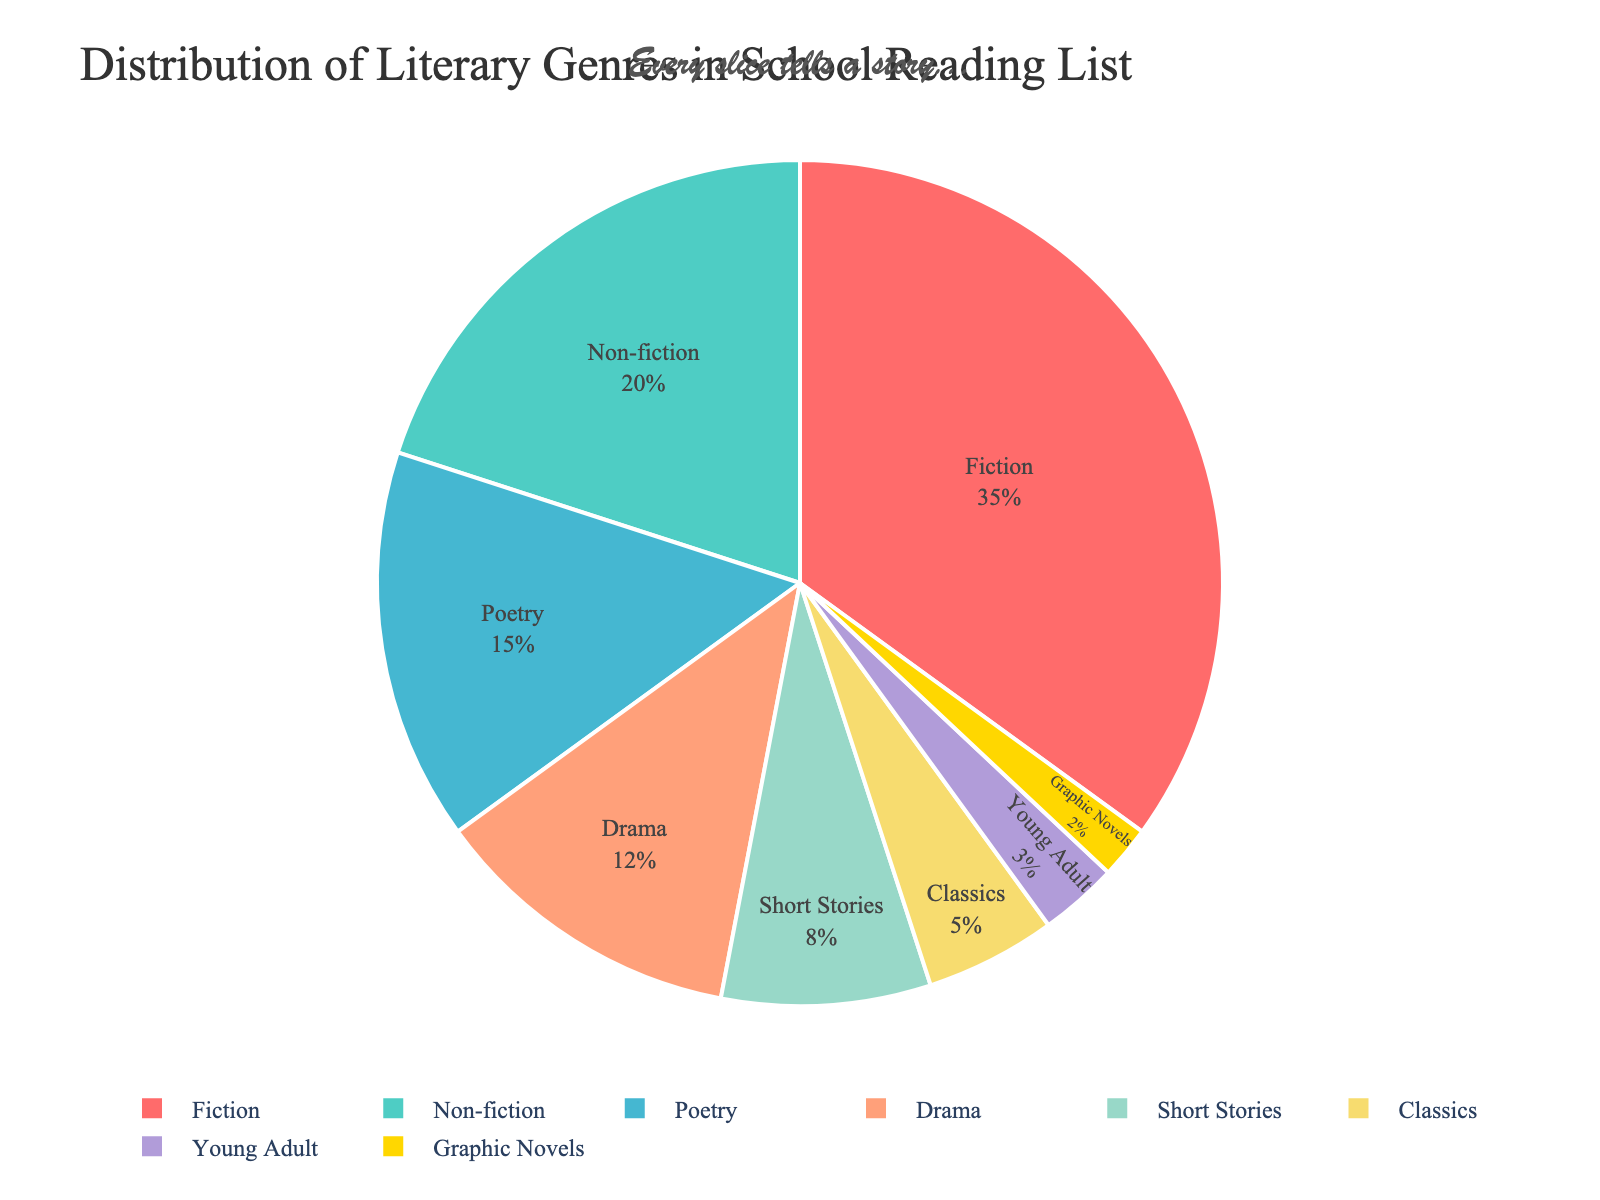What percentage of the reading list is composed of fiction and non-fiction genres combined? To determine this, look at the percentages of Fiction and Non-fiction: Fiction is 35% and Non-fiction is 20%. Adding these together, 35 + 20 = 55. Therefore, Fiction and Non-fiction combined make up 55% of the reading list.
Answer: 55% Which genre occupies the smallest portion of the pie chart? Observe the slice sizes and percentages labeled in the pie chart. Graphic Novels has the smallest slice, marked at 2%.
Answer: Graphic Novels Which is greater, the slice for Drama or the slice for Poetry? Compare the percentages directly from the chart: Poetry is 15% and Drama is 12%. Since 15% is greater than 12%, the Poetry slice is larger.
Answer: Poetry How does the percentage of Classics compare to the percentage of Young Adult genres? Look at the slices for Classics and Young Adult: Classics is 5% and Young Adult is 3%. Since 5% is greater than 3%, Classics has a larger portion.
Answer: Classics What is the difference in percentage between the largest and smallest genre slices? The largest slice is Fiction at 35%, and the smallest is Graphic Novels at 2%. Subtract the smallest from the largest: 35 - 2 = 33. Therefore, the difference is 33%.
Answer: 33% Which genre has a slice that is closest in size to that of Short Stories? Short Stories is 8%. Compare this with other slices: Classics (5%) and Young Adult (3%) are quite different. Drama is 12%. Poetry is 15%. Non-fiction is 20%. Fiction is 35%. Graphic Novels is 2%. The closest is Drama at 12%, as 8% and 12% are closer than other pairs.
Answer: Drama What is the sum of the percentages for Classics, Young Adult, and Graphic Novels? Sum up the percentages for Classics (5%), Young Adult (3%), and Graphic Novels (2%). 5 + 3 + 2 = 10. Therefore, these genres together sum to 10%.
Answer: 10% If Fiction and Non-fiction together make up more than half of the reading list, what is the combined percentage of all other genres? Fiction and Non-fiction are 55%. The entire pie chart sums to 100%. Subtract Fiction and Non-fiction: 100 - 55 = 45. Therefore, other genres combined make up 45%.
Answer: 45% How many genres have a percentage greater than 10%? Check each genre: Fiction (35%), Non-fiction (20%), Poetry (15%), Drama (12%), Short Stories (8%), Classics (5%), Young Adult (3%), Graphic Novels (2%). Only Fiction, Non-fiction, Poetry, and Drama have greater than 10%. Thus, there are 4 genres.
Answer: 4 